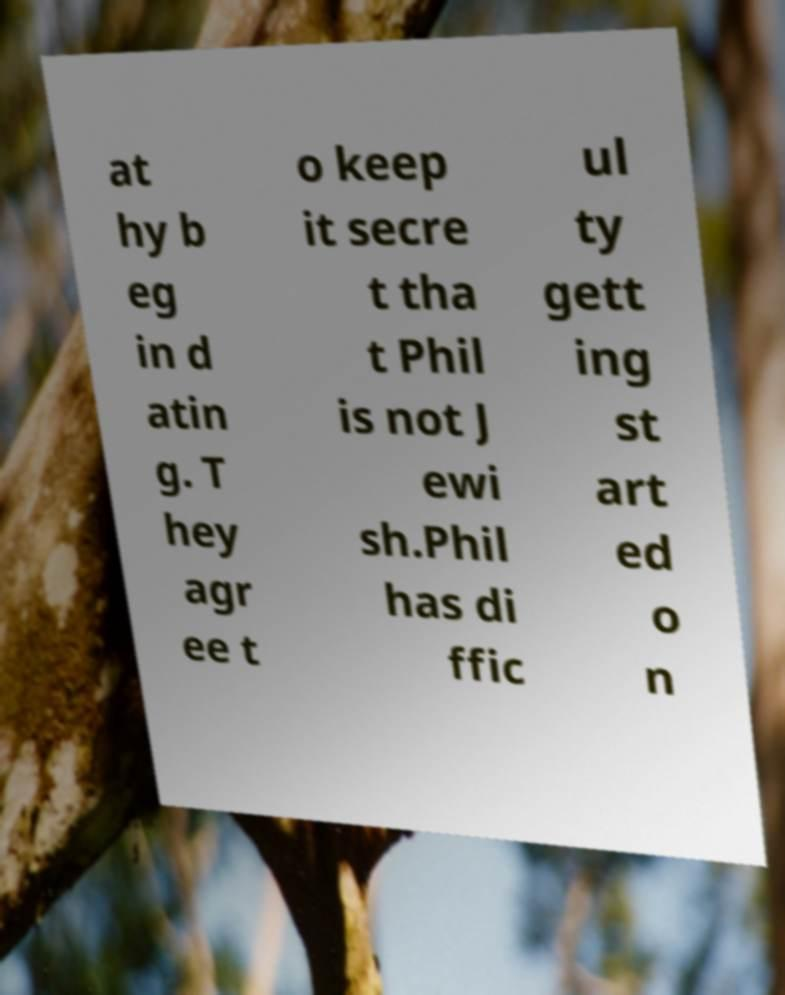What messages or text are displayed in this image? I need them in a readable, typed format. at hy b eg in d atin g. T hey agr ee t o keep it secre t tha t Phil is not J ewi sh.Phil has di ffic ul ty gett ing st art ed o n 